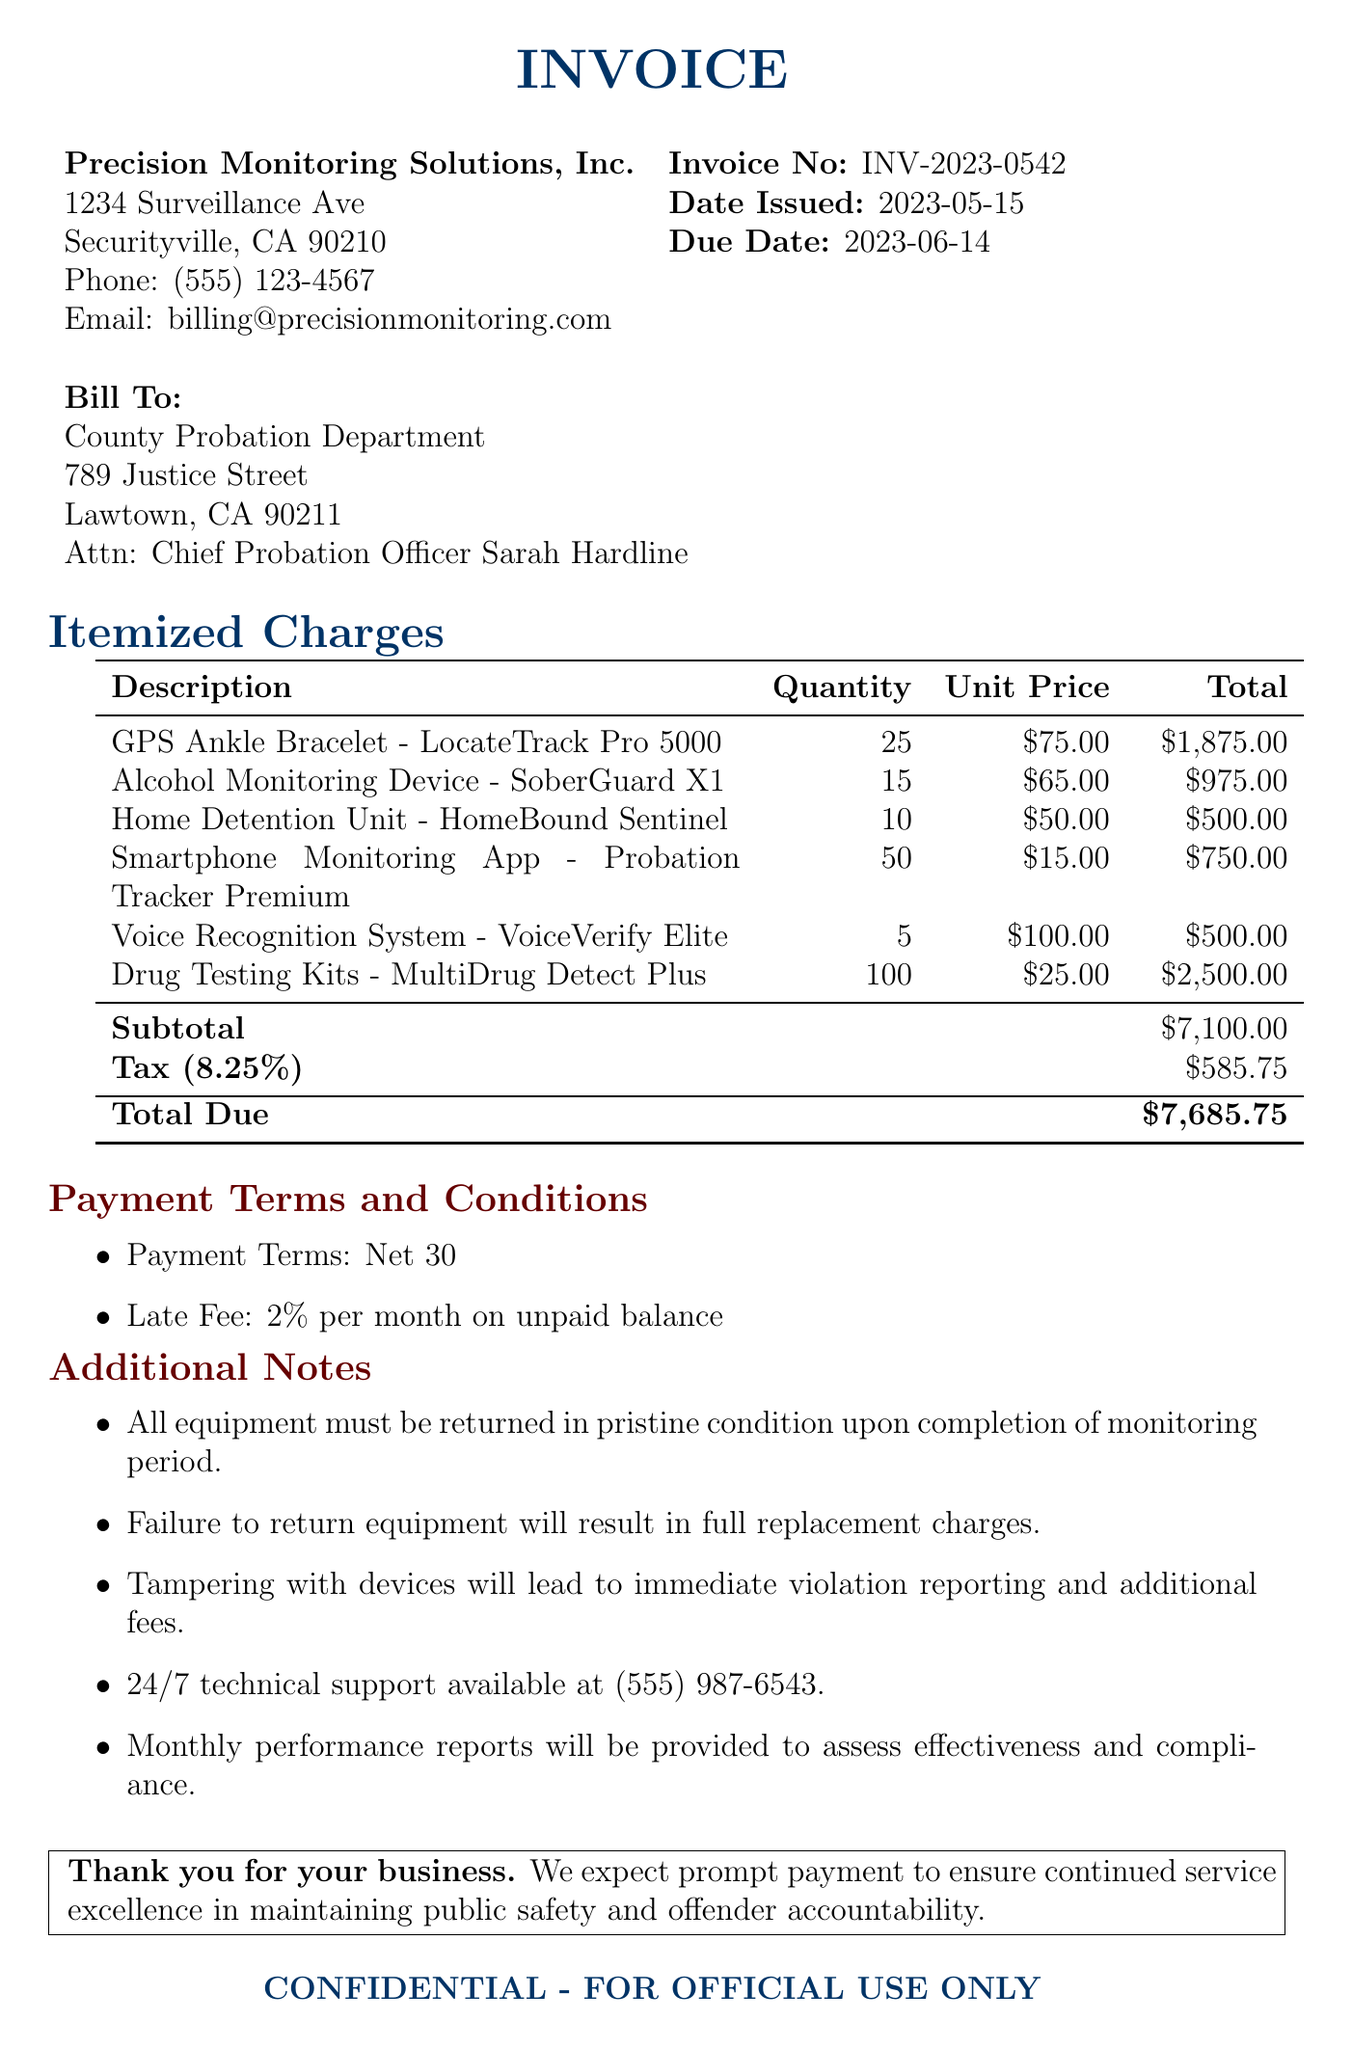What is the invoice number? The invoice number is a specific identifier for this document, which is stated clearly at the top.
Answer: INV-2023-0542 What is the due date for the payment? The due date is mentioned in the document as the date by which the payment must be made.
Answer: 2023-06-14 Who is the issuer of the invoice? The issuer's name is provided at the beginning of the document and is essential for accountability.
Answer: Precision Monitoring Solutions, Inc What is the total amount due? The total amount due is explicitly listed at the end of the invoice, representing the total cost to be paid.
Answer: $7685.75 How many GPS Ankle Bracelets are being rented? The quantity of GPS Ankle Bracelets can be found under the itemized list of charges in the document.
Answer: 25 What percentage is the tax rate applied in this invoice? The tax rate is specified in the document, indicating the percentage added to the subtotal for tax calculation.
Answer: 8.25% What is the payment term? The payment term specifies the timeframe in which the payment is expected, mentioned clearly under payment terms.
Answer: Net 30 What will happen if the equipment is not returned? The document states the consequences associated with not returning the equipment, highlighting the policy.
Answer: Full replacement charges Is technical support available for the equipment? The document includes a note about the availability of support and its contact information.
Answer: Yes, 24/7 technical support available 